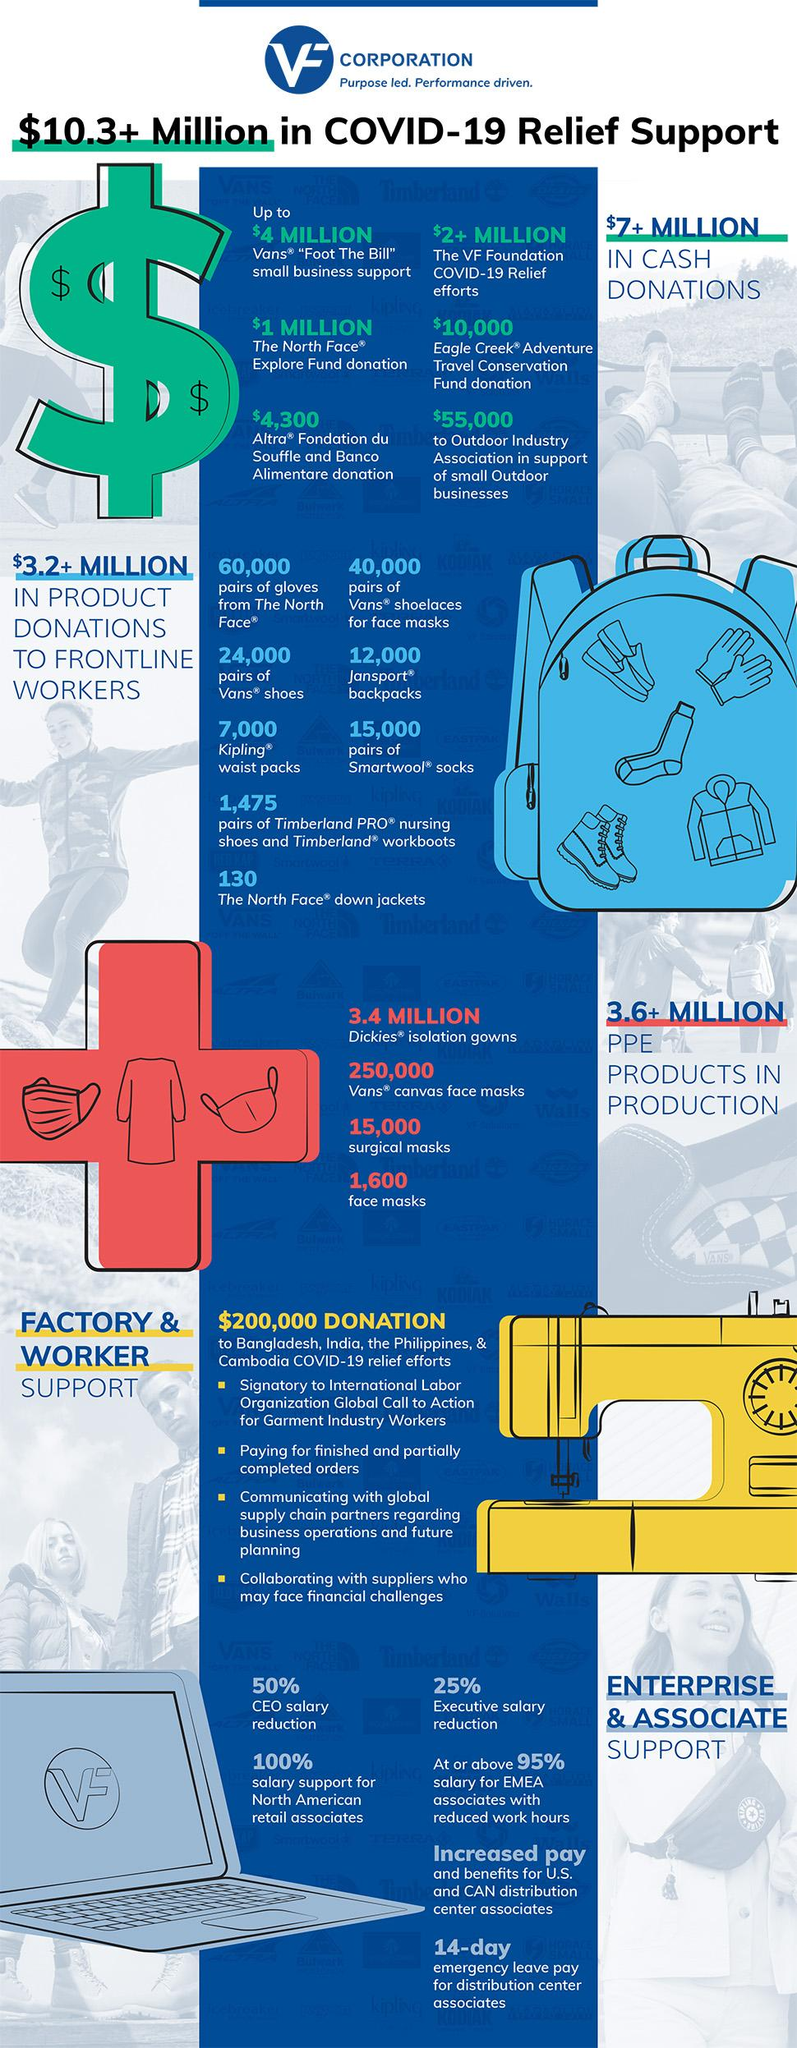Mention a couple of crucial points in this snapshot. According to the information provided, a total of $7 million has been donated in the form of cash. The product that has been donated 